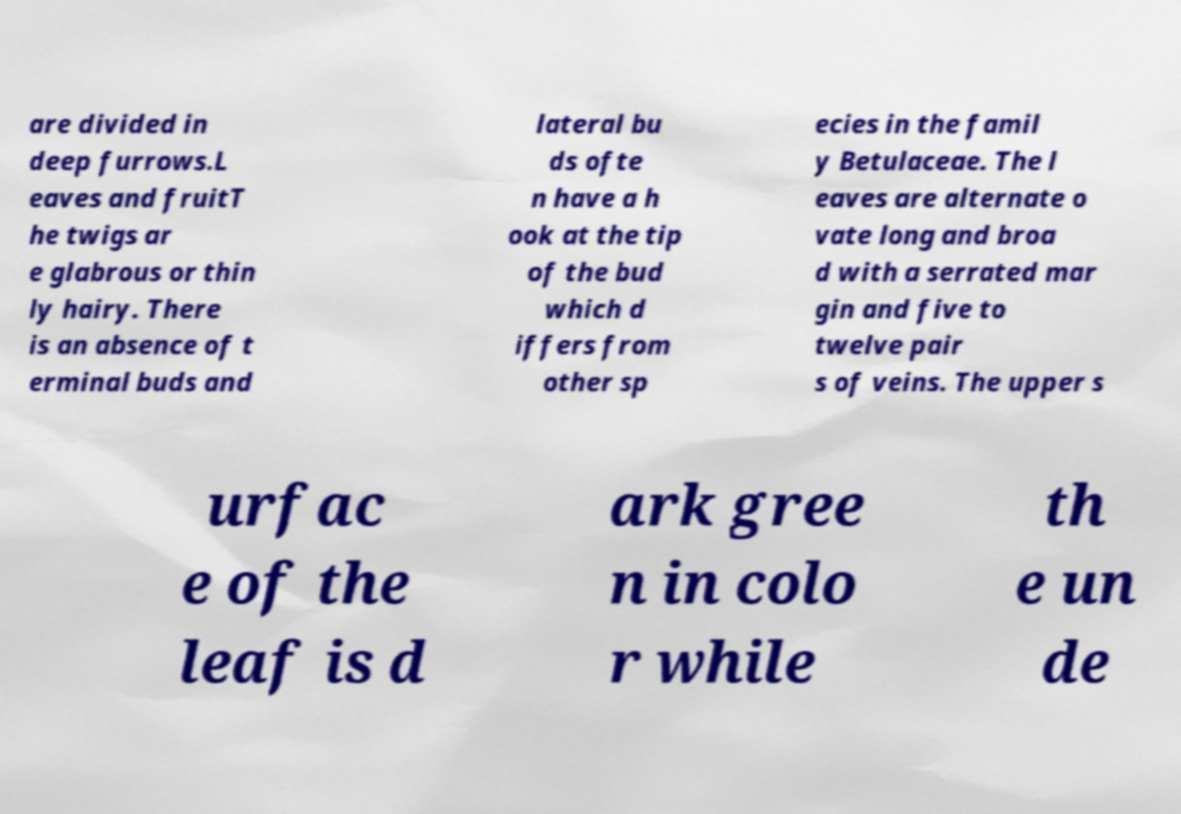For documentation purposes, I need the text within this image transcribed. Could you provide that? are divided in deep furrows.L eaves and fruitT he twigs ar e glabrous or thin ly hairy. There is an absence of t erminal buds and lateral bu ds ofte n have a h ook at the tip of the bud which d iffers from other sp ecies in the famil y Betulaceae. The l eaves are alternate o vate long and broa d with a serrated mar gin and five to twelve pair s of veins. The upper s urfac e of the leaf is d ark gree n in colo r while th e un de 